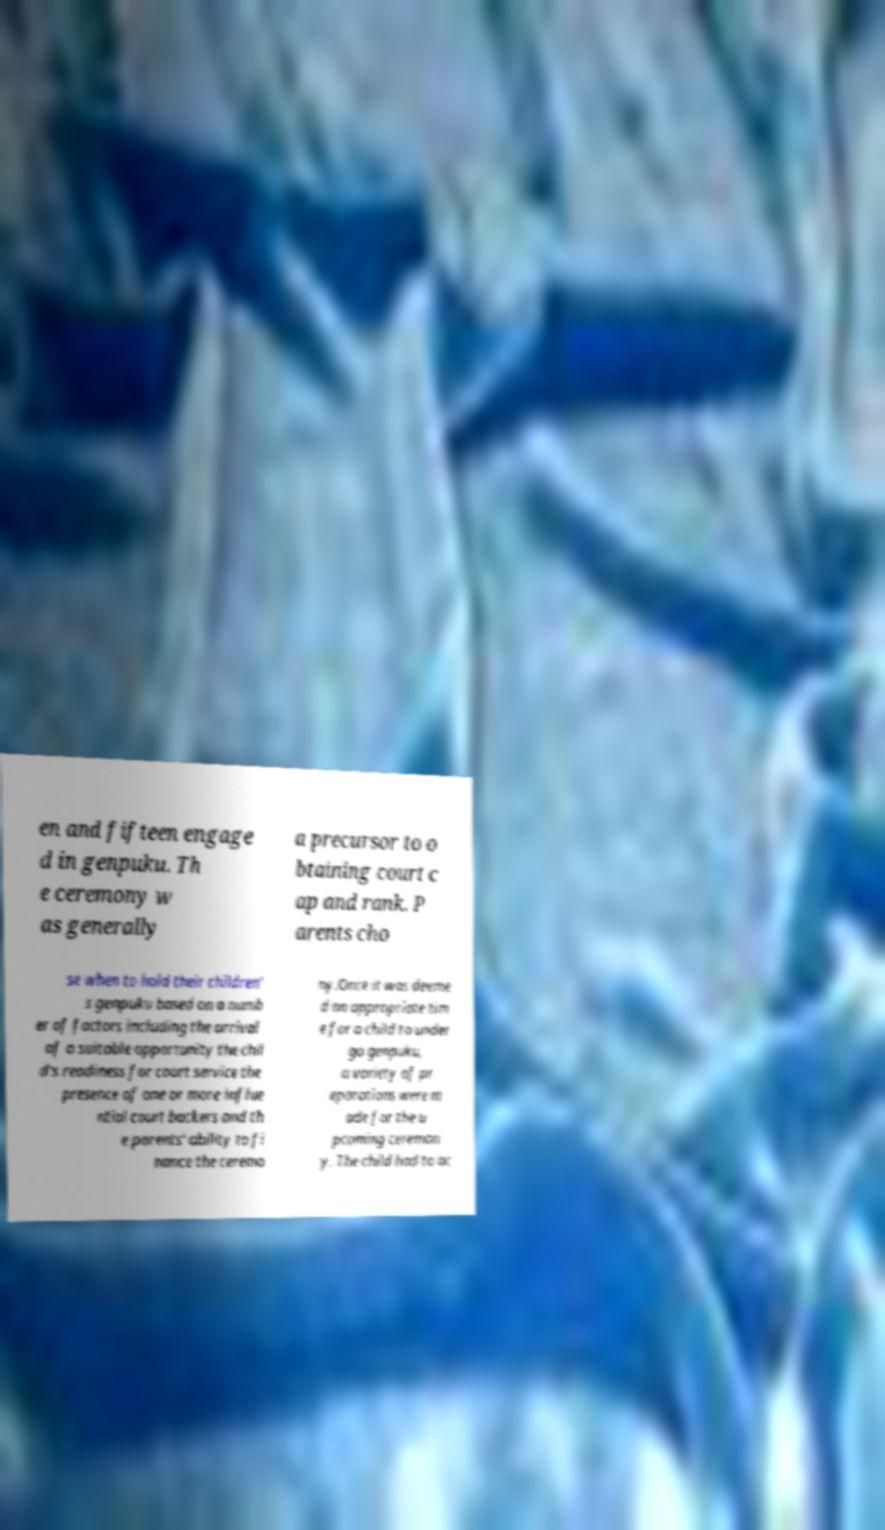Please identify and transcribe the text found in this image. en and fifteen engage d in genpuku. Th e ceremony w as generally a precursor to o btaining court c ap and rank. P arents cho se when to hold their children' s genpuku based on a numb er of factors including the arrival of a suitable opportunity the chil d's readiness for court service the presence of one or more influe ntial court backers and th e parents' ability to fi nance the ceremo ny.Once it was deeme d an appropriate tim e for a child to under go genpuku, a variety of pr eparations were m ade for the u pcoming ceremon y. The child had to ac 